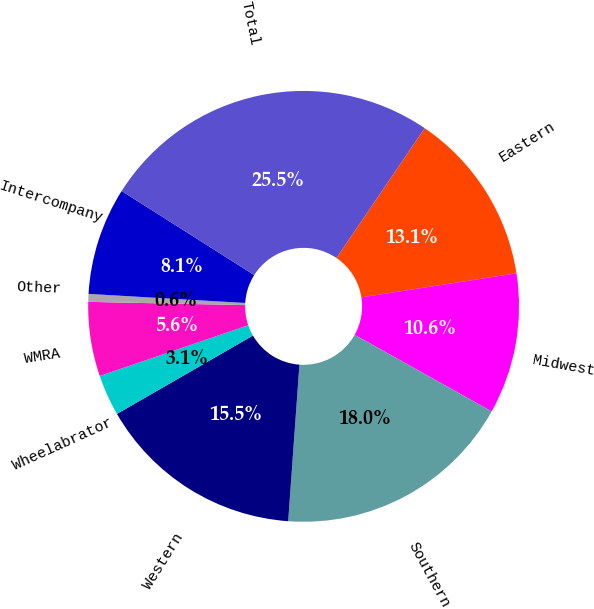Convert chart. <chart><loc_0><loc_0><loc_500><loc_500><pie_chart><fcel>Eastern<fcel>Midwest<fcel>Southern<fcel>Western<fcel>Wheelabrator<fcel>WMRA<fcel>Other<fcel>Intercompany<fcel>Total<nl><fcel>13.05%<fcel>10.56%<fcel>18.03%<fcel>15.54%<fcel>3.08%<fcel>5.57%<fcel>0.59%<fcel>8.07%<fcel>25.51%<nl></chart> 